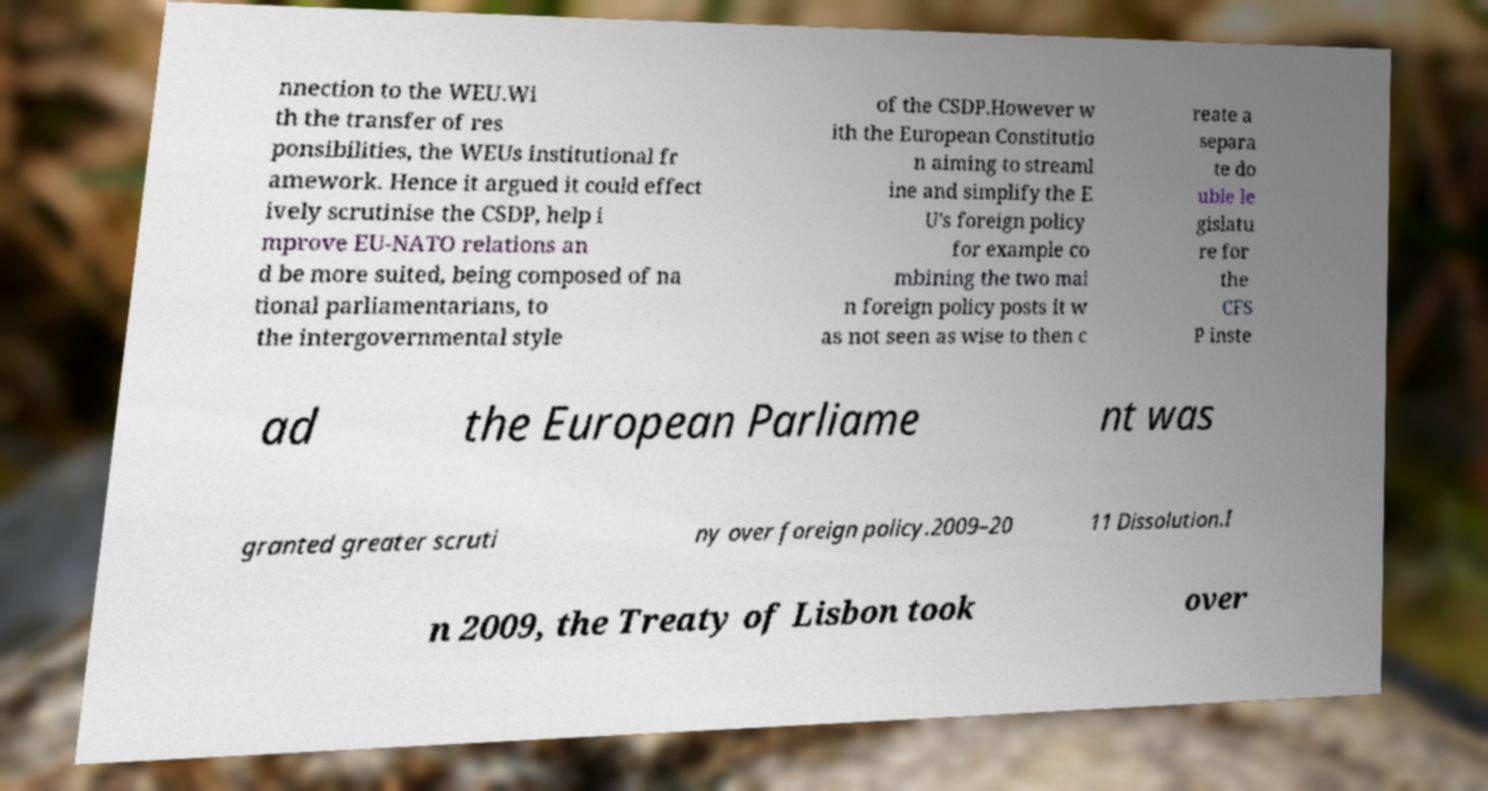Could you extract and type out the text from this image? nnection to the WEU.Wi th the transfer of res ponsibilities, the WEUs institutional fr amework. Hence it argued it could effect ively scrutinise the CSDP, help i mprove EU-NATO relations an d be more suited, being composed of na tional parliamentarians, to the intergovernmental style of the CSDP.However w ith the European Constitutio n aiming to streaml ine and simplify the E U's foreign policy for example co mbining the two mai n foreign policy posts it w as not seen as wise to then c reate a separa te do uble le gislatu re for the CFS P inste ad the European Parliame nt was granted greater scruti ny over foreign policy.2009–20 11 Dissolution.I n 2009, the Treaty of Lisbon took over 